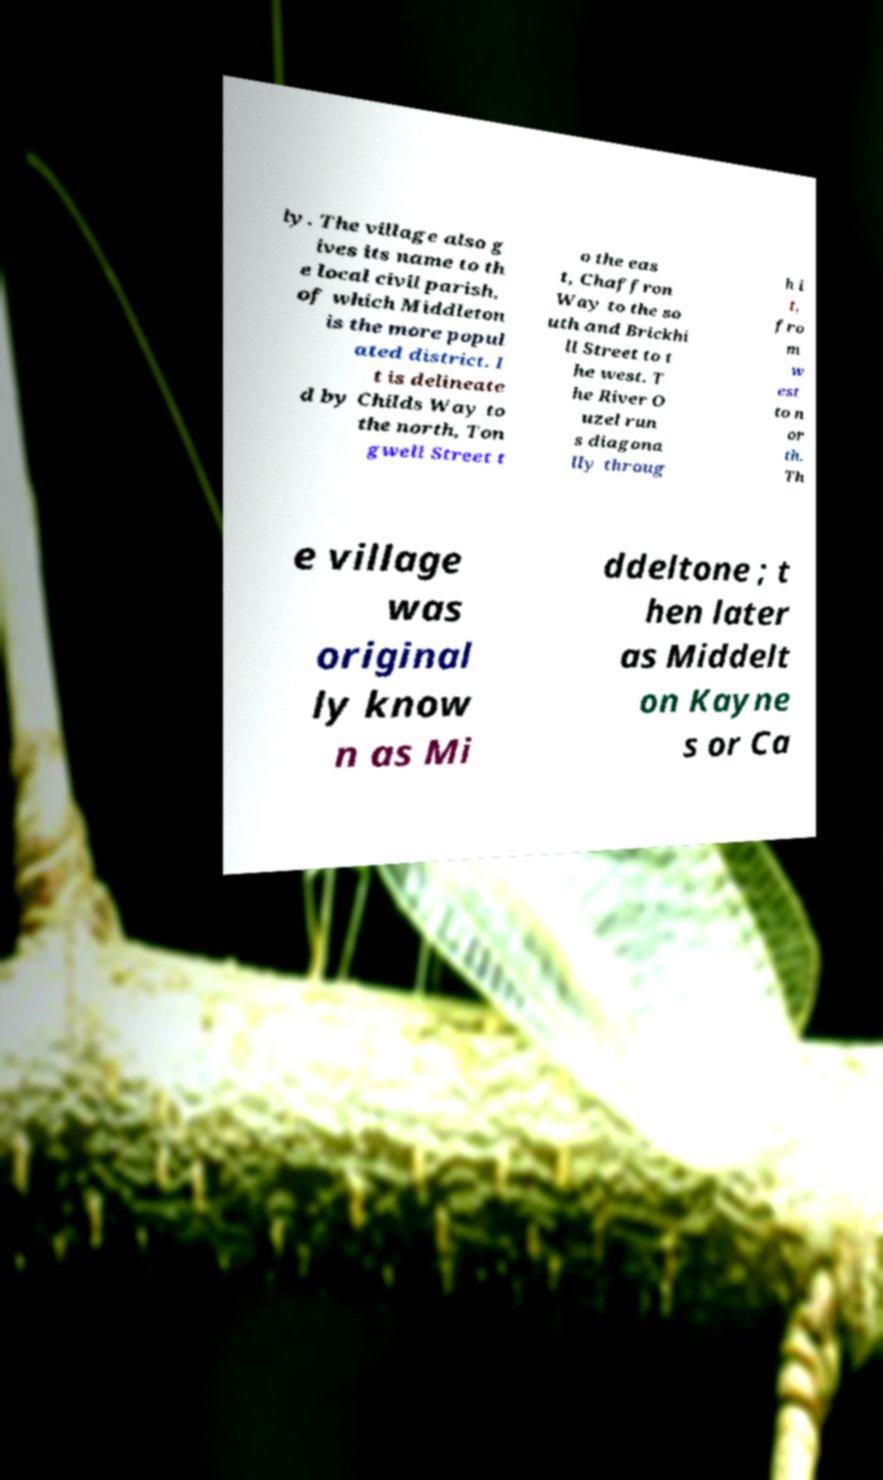Please identify and transcribe the text found in this image. ly. The village also g ives its name to th e local civil parish, of which Middleton is the more popul ated district. I t is delineate d by Childs Way to the north, Ton gwell Street t o the eas t, Chaffron Way to the so uth and Brickhi ll Street to t he west. T he River O uzel run s diagona lly throug h i t, fro m w est to n or th. Th e village was original ly know n as Mi ddeltone ; t hen later as Middelt on Kayne s or Ca 